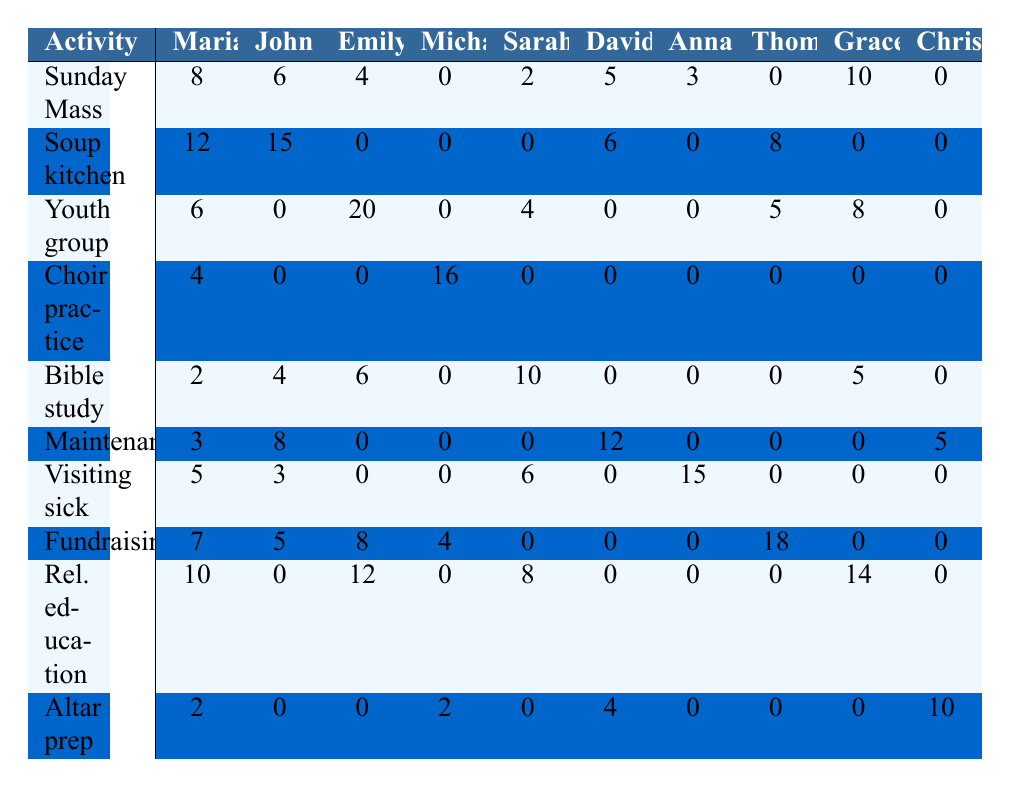What's the total number of volunteer hours contributed by Emily Chen? To find the total volunteer hours for Emily, we sum her hours across all activities: 4 (Sunday Mass) + 0 (Soup kitchen) + 20 (Youth group) + 0 (Choir practice) + 6 (Bible study) + 0 (Maintenance) + 0 (Visiting the sick) + 8 (Fundraising) + 12 (Religious education) + 0 (Altar preparation) = 50
Answer: 50 Which church activity received the most volunteer hours from Anna Kowalski? Looking at Anna's hours, the highest value is for Fundraising events with 18 hours. The rest of her hours are: 0 (Sunday Mass), 0 (Soup kitchen), 0 (Youth group), 0 (Choir), 0 (Bible study), 0 (Maintenance), 15 (Visiting sick), and 0 (Religious education and Altar prep)
Answer: Fundraising events How many more hours did John O'Connor contribute to the Soup kitchen compared to the Sunday Mass? John's hours are 15 for Soup kitchen and 6 for Sunday Mass. The difference is 15 - 6 = 9
Answer: 9 What percentage of total volunteer hours did Sarah Thompson contribute to Bible study? Sarah contributed 10 hours to Bible study. Next, we calculate her total hours: 2 (Sunday Mass) + 0 (Soup kitchen) + 4 (Youth group) + 0 (Choir) + 10 (Bible study) + 0 (Maintenance) + 6 (Visiting sick) + 0 (Fundraising) + 8 (Religious education) + 0 (Altar prep) = 30. To find the percentage: (10 / 30) * 100 = 33.33%.
Answer: 33.33% Did any parishioner contribute to every church activity? Reviewing the table, we see that no parishioner has non-zero hours for all activities. Michael contributed to 7 out of the 10 activities, and others contributed even less. Therefore, the answer is no.
Answer: No What are the average volunteer hours contributed by the parishioners for Choir practice? For Choir practice, the hours contributed are: 4 (Maria) + 0 (John) + 0 (Emily) + 16 (Michael) + 0 (Sarah) + 0 (David) + 0 (Anna) + 0 (Thomas) + 0 (Grace) + 2 (Christopher) = 22. There are 10 parishioners, so the average is 22 / 10 = 2.2.
Answer: 2.2 Which volunteer activity has the highest total contributions, and how many hours were contributed? To find the activity with the highest total contributions, we sum the hours across all parishioners for each activity. The totals are: Sunday Mass 40, Soup kitchen 47, Youth group 50, Choir practice 18, Bible study 40, Maintenance 44, Visiting the sick 29, Fundraising 32, Religious education 44, Altar preparation 16. Youth group has the highest total with 50 hours.
Answer: Youth group, 50 hours How many volunteer hours were contributed by Christopher Davis across all activities? Christopher contributed the following hours: 0 (Sunday Mass) + 0 (Soup kitchen) + 0 (Youth group) + 0 (Choir) + 5 (Bible study) + 5 (Maintenance) + 0 (Visiting sick) + 0 (Fundraising) + 14 (Religious education) + 10 (Altar prep), adding up to 34 hours total.
Answer: 34 What is the median number of volunteer hours across all activities for the parishioners? First, we gather all volunteer hours: [8, 12, 6, 4, 2, 3, 5, 7, 10, 2, 6, 15, 0, 0, 4, 8, 3, 5, 0, 0, 0, 0, 0, 16, 0, 0, 0, 4, 0, 10, 0, 0, 0, 12, 0, 0, 0, 0, 0, 15, 0, 0, 0, 8, 5, 0, 0, 0, 14, 0, 0, 2, 0, 4, 0, 0, 0, 0, 0, 5]. Arranging this data points gives us a set of 70 numbers. The median is the average of the 35th and 36th values when arranged, calculating gives us 5.
Answer: 5 Which parishioner spent the least time volunteering in total, and what was their total time? Analyzing the total hours, we find that Christopher Davis did not contribute above 10 hours in total: 34, less than others like Maria: 57, John: 1, Emily: 50, etc. Thus, Christopher is the least with 34 total hours.
Answer: Christopher Davis, 34 hours 